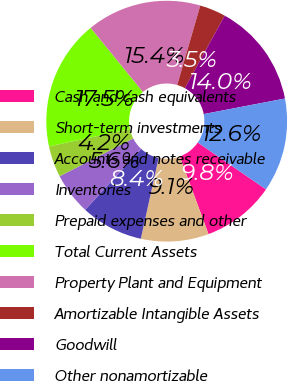Convert chart. <chart><loc_0><loc_0><loc_500><loc_500><pie_chart><fcel>Cash and cash equivalents<fcel>Short-term investments<fcel>Accounts and notes receivable<fcel>Inventories<fcel>Prepaid expenses and other<fcel>Total Current Assets<fcel>Property Plant and Equipment<fcel>Amortizable Intangible Assets<fcel>Goodwill<fcel>Other nonamortizable<nl><fcel>9.79%<fcel>9.09%<fcel>8.39%<fcel>5.6%<fcel>4.2%<fcel>17.48%<fcel>15.38%<fcel>3.5%<fcel>13.99%<fcel>12.59%<nl></chart> 